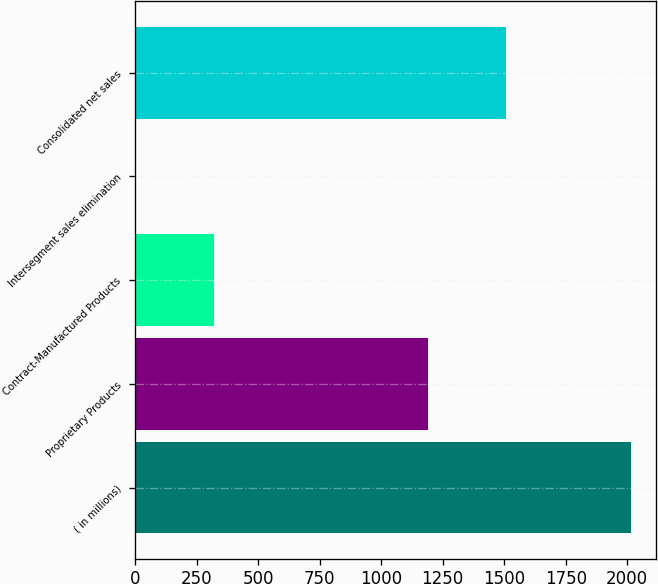<chart> <loc_0><loc_0><loc_500><loc_500><bar_chart><fcel>( in millions)<fcel>Proprietary Products<fcel>Contract-Manufactured Products<fcel>Intersegment sales elimination<fcel>Consolidated net sales<nl><fcel>2016<fcel>1189.9<fcel>320.2<fcel>1<fcel>1509.1<nl></chart> 